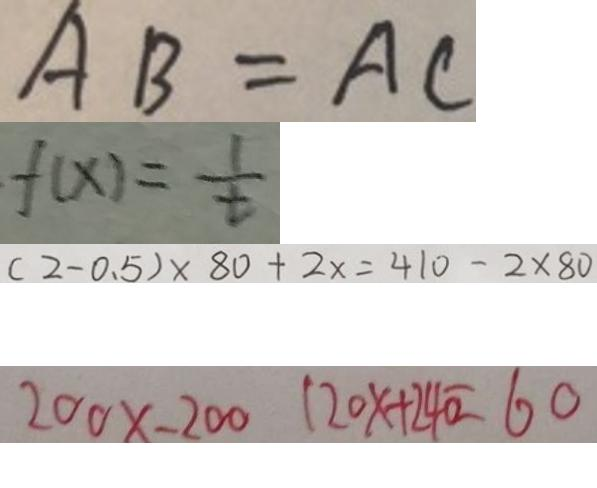Convert formula to latex. <formula><loc_0><loc_0><loc_500><loc_500>A B = A C 
 f ( x ) = \frac { 1 } { t } 
 ( 2 - 0 . 5 ) \times 8 0 + 2 x = 4 1 0 - 2 \times 8 0 
 2 0 0 \times - 2 0 0 1 2 0 x + 2 4 0 = 6 0</formula> 